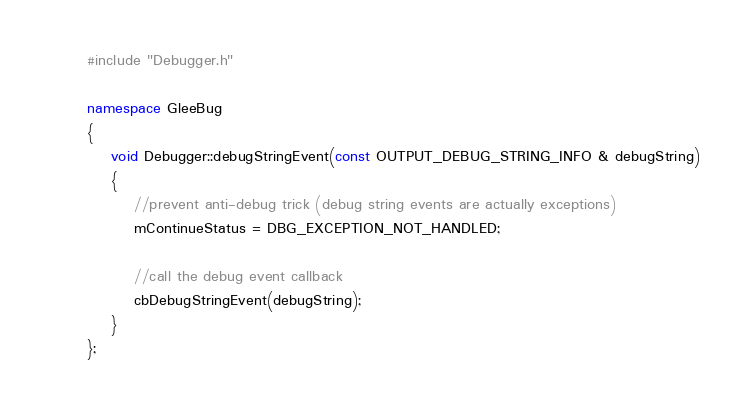<code> <loc_0><loc_0><loc_500><loc_500><_C++_>#include "Debugger.h"

namespace GleeBug
{
    void Debugger::debugStringEvent(const OUTPUT_DEBUG_STRING_INFO & debugString)
    {
        //prevent anti-debug trick (debug string events are actually exceptions)
        mContinueStatus = DBG_EXCEPTION_NOT_HANDLED;

        //call the debug event callback
        cbDebugStringEvent(debugString);
    }
};</code> 